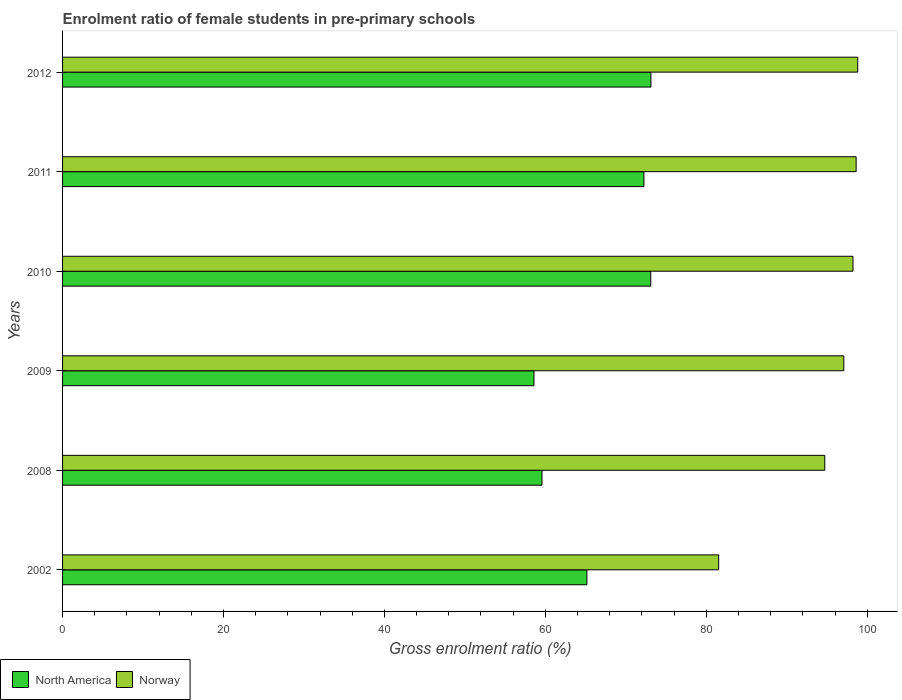How many different coloured bars are there?
Offer a very short reply. 2. Are the number of bars per tick equal to the number of legend labels?
Provide a succinct answer. Yes. How many bars are there on the 4th tick from the bottom?
Your answer should be compact. 2. What is the enrolment ratio of female students in pre-primary schools in Norway in 2010?
Your answer should be very brief. 98.23. Across all years, what is the maximum enrolment ratio of female students in pre-primary schools in Norway?
Keep it short and to the point. 98.82. Across all years, what is the minimum enrolment ratio of female students in pre-primary schools in North America?
Offer a very short reply. 58.59. In which year was the enrolment ratio of female students in pre-primary schools in Norway maximum?
Give a very brief answer. 2012. What is the total enrolment ratio of female students in pre-primary schools in North America in the graph?
Give a very brief answer. 401.81. What is the difference between the enrolment ratio of female students in pre-primary schools in North America in 2002 and that in 2011?
Make the answer very short. -7.09. What is the difference between the enrolment ratio of female students in pre-primary schools in North America in 2010 and the enrolment ratio of female students in pre-primary schools in Norway in 2008?
Offer a terse response. -21.63. What is the average enrolment ratio of female students in pre-primary schools in Norway per year?
Give a very brief answer. 94.84. In the year 2012, what is the difference between the enrolment ratio of female students in pre-primary schools in North America and enrolment ratio of female students in pre-primary schools in Norway?
Your answer should be very brief. -25.7. In how many years, is the enrolment ratio of female students in pre-primary schools in Norway greater than 96 %?
Offer a terse response. 4. What is the ratio of the enrolment ratio of female students in pre-primary schools in Norway in 2002 to that in 2008?
Ensure brevity in your answer.  0.86. Is the difference between the enrolment ratio of female students in pre-primary schools in North America in 2008 and 2010 greater than the difference between the enrolment ratio of female students in pre-primary schools in Norway in 2008 and 2010?
Provide a short and direct response. No. What is the difference between the highest and the second highest enrolment ratio of female students in pre-primary schools in North America?
Give a very brief answer. 0.02. What is the difference between the highest and the lowest enrolment ratio of female students in pre-primary schools in North America?
Provide a short and direct response. 14.53. In how many years, is the enrolment ratio of female students in pre-primary schools in North America greater than the average enrolment ratio of female students in pre-primary schools in North America taken over all years?
Keep it short and to the point. 3. What does the 2nd bar from the top in 2012 represents?
Your answer should be compact. North America. What does the 2nd bar from the bottom in 2012 represents?
Your answer should be very brief. Norway. Are the values on the major ticks of X-axis written in scientific E-notation?
Ensure brevity in your answer.  No. Does the graph contain any zero values?
Offer a very short reply. No. Where does the legend appear in the graph?
Provide a short and direct response. Bottom left. How many legend labels are there?
Your answer should be compact. 2. How are the legend labels stacked?
Offer a very short reply. Horizontal. What is the title of the graph?
Keep it short and to the point. Enrolment ratio of female students in pre-primary schools. Does "Sri Lanka" appear as one of the legend labels in the graph?
Keep it short and to the point. No. What is the label or title of the X-axis?
Provide a short and direct response. Gross enrolment ratio (%). What is the label or title of the Y-axis?
Your response must be concise. Years. What is the Gross enrolment ratio (%) of North America in 2002?
Give a very brief answer. 65.16. What is the Gross enrolment ratio (%) of Norway in 2002?
Your response must be concise. 81.54. What is the Gross enrolment ratio (%) in North America in 2008?
Ensure brevity in your answer.  59.58. What is the Gross enrolment ratio (%) in Norway in 2008?
Keep it short and to the point. 94.73. What is the Gross enrolment ratio (%) of North America in 2009?
Provide a succinct answer. 58.59. What is the Gross enrolment ratio (%) of Norway in 2009?
Your answer should be compact. 97.09. What is the Gross enrolment ratio (%) of North America in 2010?
Make the answer very short. 73.1. What is the Gross enrolment ratio (%) in Norway in 2010?
Offer a terse response. 98.23. What is the Gross enrolment ratio (%) of North America in 2011?
Your answer should be compact. 72.25. What is the Gross enrolment ratio (%) in Norway in 2011?
Offer a very short reply. 98.63. What is the Gross enrolment ratio (%) of North America in 2012?
Your response must be concise. 73.12. What is the Gross enrolment ratio (%) of Norway in 2012?
Ensure brevity in your answer.  98.82. Across all years, what is the maximum Gross enrolment ratio (%) of North America?
Provide a succinct answer. 73.12. Across all years, what is the maximum Gross enrolment ratio (%) in Norway?
Keep it short and to the point. 98.82. Across all years, what is the minimum Gross enrolment ratio (%) in North America?
Your answer should be very brief. 58.59. Across all years, what is the minimum Gross enrolment ratio (%) of Norway?
Your response must be concise. 81.54. What is the total Gross enrolment ratio (%) of North America in the graph?
Offer a very short reply. 401.81. What is the total Gross enrolment ratio (%) of Norway in the graph?
Provide a succinct answer. 569.04. What is the difference between the Gross enrolment ratio (%) in North America in 2002 and that in 2008?
Offer a very short reply. 5.58. What is the difference between the Gross enrolment ratio (%) in Norway in 2002 and that in 2008?
Keep it short and to the point. -13.19. What is the difference between the Gross enrolment ratio (%) of North America in 2002 and that in 2009?
Give a very brief answer. 6.58. What is the difference between the Gross enrolment ratio (%) in Norway in 2002 and that in 2009?
Provide a succinct answer. -15.55. What is the difference between the Gross enrolment ratio (%) in North America in 2002 and that in 2010?
Your answer should be compact. -7.93. What is the difference between the Gross enrolment ratio (%) in Norway in 2002 and that in 2010?
Offer a terse response. -16.69. What is the difference between the Gross enrolment ratio (%) in North America in 2002 and that in 2011?
Make the answer very short. -7.09. What is the difference between the Gross enrolment ratio (%) of Norway in 2002 and that in 2011?
Provide a short and direct response. -17.08. What is the difference between the Gross enrolment ratio (%) of North America in 2002 and that in 2012?
Provide a succinct answer. -7.96. What is the difference between the Gross enrolment ratio (%) in Norway in 2002 and that in 2012?
Your answer should be very brief. -17.28. What is the difference between the Gross enrolment ratio (%) of Norway in 2008 and that in 2009?
Make the answer very short. -2.37. What is the difference between the Gross enrolment ratio (%) in North America in 2008 and that in 2010?
Keep it short and to the point. -13.52. What is the difference between the Gross enrolment ratio (%) in Norway in 2008 and that in 2010?
Keep it short and to the point. -3.5. What is the difference between the Gross enrolment ratio (%) of North America in 2008 and that in 2011?
Your response must be concise. -12.67. What is the difference between the Gross enrolment ratio (%) in Norway in 2008 and that in 2011?
Give a very brief answer. -3.9. What is the difference between the Gross enrolment ratio (%) of North America in 2008 and that in 2012?
Your answer should be compact. -13.54. What is the difference between the Gross enrolment ratio (%) of Norway in 2008 and that in 2012?
Your answer should be compact. -4.1. What is the difference between the Gross enrolment ratio (%) in North America in 2009 and that in 2010?
Make the answer very short. -14.51. What is the difference between the Gross enrolment ratio (%) in Norway in 2009 and that in 2010?
Offer a very short reply. -1.14. What is the difference between the Gross enrolment ratio (%) of North America in 2009 and that in 2011?
Give a very brief answer. -13.67. What is the difference between the Gross enrolment ratio (%) of Norway in 2009 and that in 2011?
Your answer should be compact. -1.53. What is the difference between the Gross enrolment ratio (%) in North America in 2009 and that in 2012?
Your answer should be very brief. -14.53. What is the difference between the Gross enrolment ratio (%) of Norway in 2009 and that in 2012?
Provide a short and direct response. -1.73. What is the difference between the Gross enrolment ratio (%) in North America in 2010 and that in 2011?
Offer a very short reply. 0.85. What is the difference between the Gross enrolment ratio (%) in Norway in 2010 and that in 2011?
Give a very brief answer. -0.39. What is the difference between the Gross enrolment ratio (%) in North America in 2010 and that in 2012?
Your answer should be compact. -0.02. What is the difference between the Gross enrolment ratio (%) of Norway in 2010 and that in 2012?
Keep it short and to the point. -0.59. What is the difference between the Gross enrolment ratio (%) in North America in 2011 and that in 2012?
Your answer should be very brief. -0.87. What is the difference between the Gross enrolment ratio (%) of Norway in 2011 and that in 2012?
Give a very brief answer. -0.2. What is the difference between the Gross enrolment ratio (%) in North America in 2002 and the Gross enrolment ratio (%) in Norway in 2008?
Offer a very short reply. -29.56. What is the difference between the Gross enrolment ratio (%) in North America in 2002 and the Gross enrolment ratio (%) in Norway in 2009?
Offer a terse response. -31.93. What is the difference between the Gross enrolment ratio (%) in North America in 2002 and the Gross enrolment ratio (%) in Norway in 2010?
Provide a short and direct response. -33.07. What is the difference between the Gross enrolment ratio (%) of North America in 2002 and the Gross enrolment ratio (%) of Norway in 2011?
Give a very brief answer. -33.46. What is the difference between the Gross enrolment ratio (%) of North America in 2002 and the Gross enrolment ratio (%) of Norway in 2012?
Offer a very short reply. -33.66. What is the difference between the Gross enrolment ratio (%) in North America in 2008 and the Gross enrolment ratio (%) in Norway in 2009?
Offer a terse response. -37.51. What is the difference between the Gross enrolment ratio (%) of North America in 2008 and the Gross enrolment ratio (%) of Norway in 2010?
Keep it short and to the point. -38.65. What is the difference between the Gross enrolment ratio (%) of North America in 2008 and the Gross enrolment ratio (%) of Norway in 2011?
Your answer should be compact. -39.04. What is the difference between the Gross enrolment ratio (%) of North America in 2008 and the Gross enrolment ratio (%) of Norway in 2012?
Your answer should be compact. -39.24. What is the difference between the Gross enrolment ratio (%) of North America in 2009 and the Gross enrolment ratio (%) of Norway in 2010?
Offer a terse response. -39.64. What is the difference between the Gross enrolment ratio (%) of North America in 2009 and the Gross enrolment ratio (%) of Norway in 2011?
Provide a succinct answer. -40.04. What is the difference between the Gross enrolment ratio (%) of North America in 2009 and the Gross enrolment ratio (%) of Norway in 2012?
Your answer should be compact. -40.24. What is the difference between the Gross enrolment ratio (%) in North America in 2010 and the Gross enrolment ratio (%) in Norway in 2011?
Make the answer very short. -25.53. What is the difference between the Gross enrolment ratio (%) in North America in 2010 and the Gross enrolment ratio (%) in Norway in 2012?
Make the answer very short. -25.72. What is the difference between the Gross enrolment ratio (%) in North America in 2011 and the Gross enrolment ratio (%) in Norway in 2012?
Make the answer very short. -26.57. What is the average Gross enrolment ratio (%) of North America per year?
Provide a succinct answer. 66.97. What is the average Gross enrolment ratio (%) in Norway per year?
Make the answer very short. 94.84. In the year 2002, what is the difference between the Gross enrolment ratio (%) in North America and Gross enrolment ratio (%) in Norway?
Your response must be concise. -16.38. In the year 2008, what is the difference between the Gross enrolment ratio (%) of North America and Gross enrolment ratio (%) of Norway?
Provide a succinct answer. -35.14. In the year 2009, what is the difference between the Gross enrolment ratio (%) of North America and Gross enrolment ratio (%) of Norway?
Keep it short and to the point. -38.51. In the year 2010, what is the difference between the Gross enrolment ratio (%) in North America and Gross enrolment ratio (%) in Norway?
Provide a short and direct response. -25.13. In the year 2011, what is the difference between the Gross enrolment ratio (%) of North America and Gross enrolment ratio (%) of Norway?
Offer a terse response. -26.37. In the year 2012, what is the difference between the Gross enrolment ratio (%) in North America and Gross enrolment ratio (%) in Norway?
Your answer should be compact. -25.7. What is the ratio of the Gross enrolment ratio (%) in North America in 2002 to that in 2008?
Provide a succinct answer. 1.09. What is the ratio of the Gross enrolment ratio (%) of Norway in 2002 to that in 2008?
Ensure brevity in your answer.  0.86. What is the ratio of the Gross enrolment ratio (%) of North America in 2002 to that in 2009?
Offer a very short reply. 1.11. What is the ratio of the Gross enrolment ratio (%) of Norway in 2002 to that in 2009?
Your answer should be compact. 0.84. What is the ratio of the Gross enrolment ratio (%) of North America in 2002 to that in 2010?
Make the answer very short. 0.89. What is the ratio of the Gross enrolment ratio (%) of Norway in 2002 to that in 2010?
Your response must be concise. 0.83. What is the ratio of the Gross enrolment ratio (%) in North America in 2002 to that in 2011?
Make the answer very short. 0.9. What is the ratio of the Gross enrolment ratio (%) of Norway in 2002 to that in 2011?
Provide a short and direct response. 0.83. What is the ratio of the Gross enrolment ratio (%) in North America in 2002 to that in 2012?
Provide a short and direct response. 0.89. What is the ratio of the Gross enrolment ratio (%) in Norway in 2002 to that in 2012?
Your answer should be compact. 0.83. What is the ratio of the Gross enrolment ratio (%) of North America in 2008 to that in 2009?
Keep it short and to the point. 1.02. What is the ratio of the Gross enrolment ratio (%) of Norway in 2008 to that in 2009?
Offer a very short reply. 0.98. What is the ratio of the Gross enrolment ratio (%) of North America in 2008 to that in 2010?
Make the answer very short. 0.82. What is the ratio of the Gross enrolment ratio (%) of Norway in 2008 to that in 2010?
Ensure brevity in your answer.  0.96. What is the ratio of the Gross enrolment ratio (%) in North America in 2008 to that in 2011?
Ensure brevity in your answer.  0.82. What is the ratio of the Gross enrolment ratio (%) in Norway in 2008 to that in 2011?
Ensure brevity in your answer.  0.96. What is the ratio of the Gross enrolment ratio (%) of North America in 2008 to that in 2012?
Ensure brevity in your answer.  0.81. What is the ratio of the Gross enrolment ratio (%) in Norway in 2008 to that in 2012?
Provide a short and direct response. 0.96. What is the ratio of the Gross enrolment ratio (%) in North America in 2009 to that in 2010?
Provide a short and direct response. 0.8. What is the ratio of the Gross enrolment ratio (%) of Norway in 2009 to that in 2010?
Keep it short and to the point. 0.99. What is the ratio of the Gross enrolment ratio (%) in North America in 2009 to that in 2011?
Offer a terse response. 0.81. What is the ratio of the Gross enrolment ratio (%) of Norway in 2009 to that in 2011?
Offer a very short reply. 0.98. What is the ratio of the Gross enrolment ratio (%) in North America in 2009 to that in 2012?
Offer a terse response. 0.8. What is the ratio of the Gross enrolment ratio (%) in Norway in 2009 to that in 2012?
Your answer should be very brief. 0.98. What is the ratio of the Gross enrolment ratio (%) in North America in 2010 to that in 2011?
Offer a terse response. 1.01. What is the ratio of the Gross enrolment ratio (%) of North America in 2010 to that in 2012?
Make the answer very short. 1. What is the ratio of the Gross enrolment ratio (%) in Norway in 2010 to that in 2012?
Make the answer very short. 0.99. What is the difference between the highest and the second highest Gross enrolment ratio (%) in North America?
Your response must be concise. 0.02. What is the difference between the highest and the second highest Gross enrolment ratio (%) in Norway?
Your answer should be very brief. 0.2. What is the difference between the highest and the lowest Gross enrolment ratio (%) in North America?
Offer a very short reply. 14.53. What is the difference between the highest and the lowest Gross enrolment ratio (%) of Norway?
Provide a short and direct response. 17.28. 